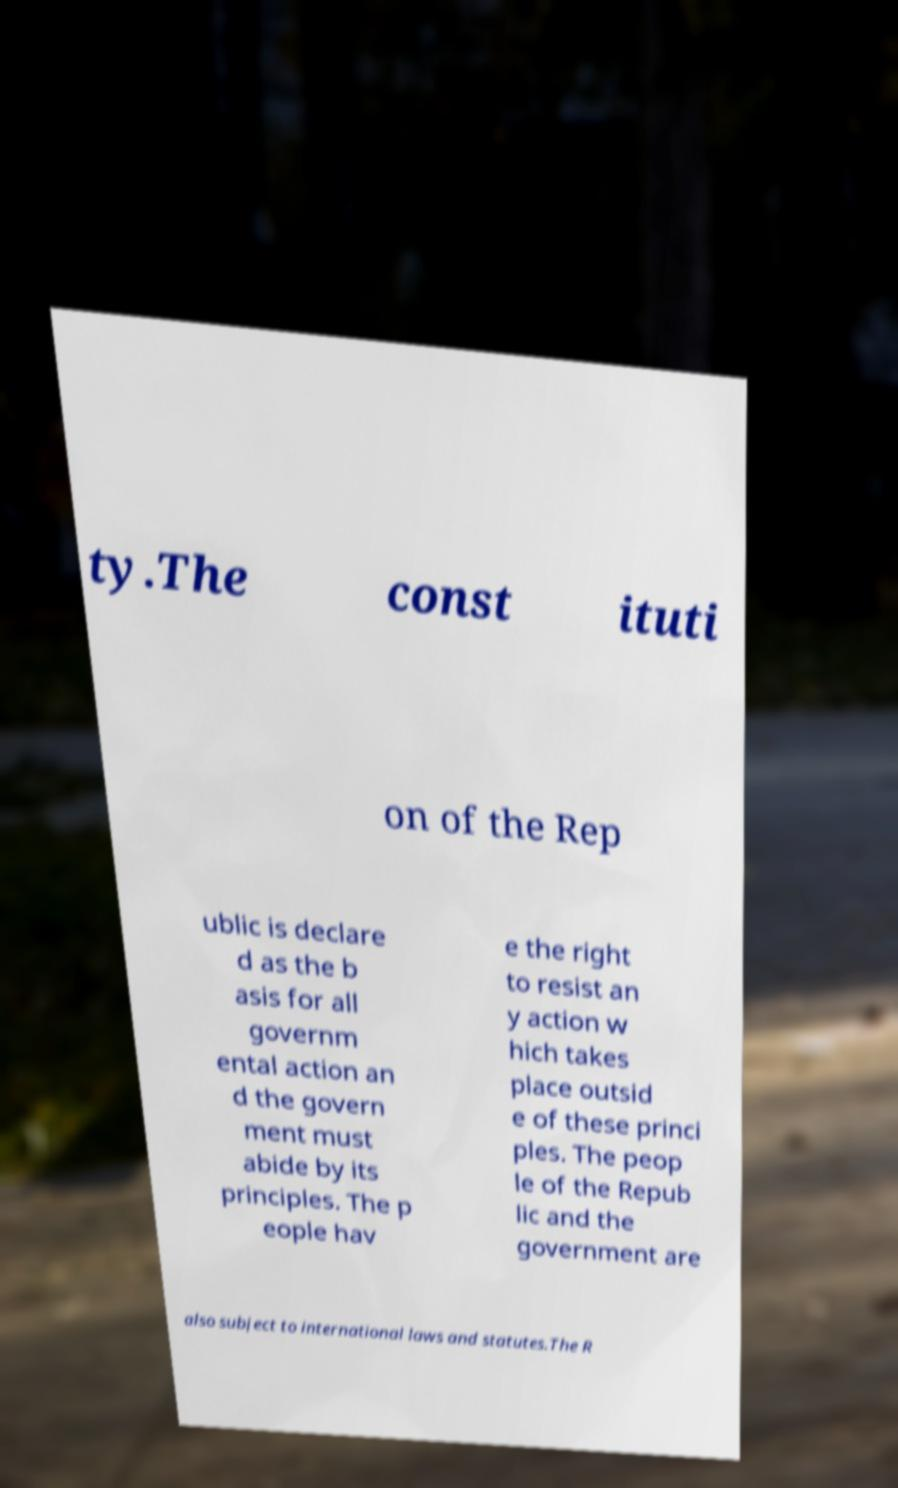Please read and relay the text visible in this image. What does it say? ty.The const ituti on of the Rep ublic is declare d as the b asis for all governm ental action an d the govern ment must abide by its principles. The p eople hav e the right to resist an y action w hich takes place outsid e of these princi ples. The peop le of the Repub lic and the government are also subject to international laws and statutes.The R 